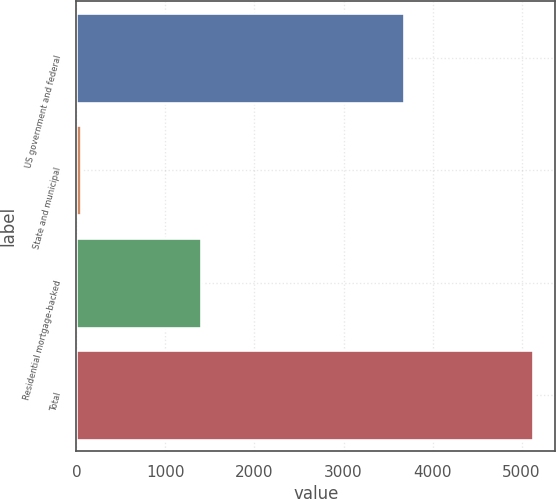Convert chart. <chart><loc_0><loc_0><loc_500><loc_500><bar_chart><fcel>US government and federal<fcel>State and municipal<fcel>Residential mortgage-backed<fcel>Total<nl><fcel>3676<fcel>47<fcel>1400<fcel>5123<nl></chart> 